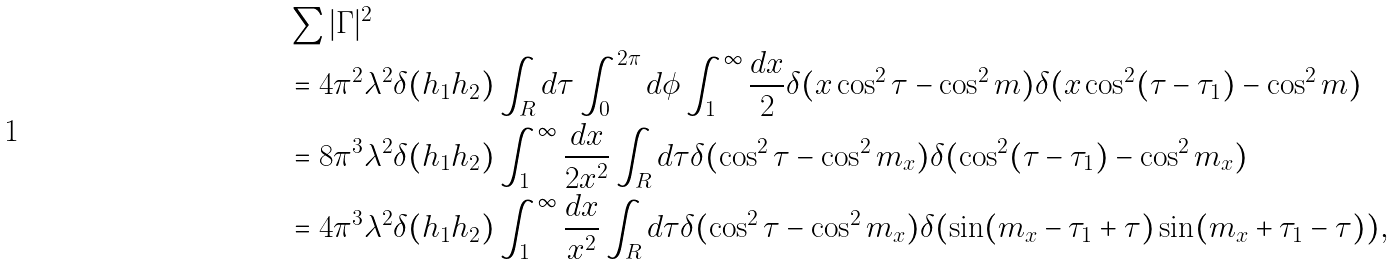Convert formula to latex. <formula><loc_0><loc_0><loc_500><loc_500>& \sum | \Gamma | ^ { 2 } \\ & = 4 \pi ^ { 2 } \lambda ^ { 2 } \delta ( h _ { 1 } h _ { 2 } ) \int _ { R } d \tau \int _ { 0 } ^ { 2 \pi } d \phi \int _ { 1 } ^ { \infty } \frac { d x } { 2 } \delta ( x \cos ^ { 2 } \tau - \cos ^ { 2 } m ) \delta ( x \cos ^ { 2 } ( \tau - \tau _ { 1 } ) - \cos ^ { 2 } m ) \\ & = 8 \pi ^ { 3 } \lambda ^ { 2 } \delta ( h _ { 1 } h _ { 2 } ) \int _ { 1 } ^ { \infty } \frac { d x } { 2 x ^ { 2 } } \int _ { R } d \tau \delta ( \cos ^ { 2 } \tau - \cos ^ { 2 } m _ { x } ) \delta ( \cos ^ { 2 } ( \tau - \tau _ { 1 } ) - \cos ^ { 2 } m _ { x } ) \\ & = 4 \pi ^ { 3 } \lambda ^ { 2 } \delta ( h _ { 1 } h _ { 2 } ) \int _ { 1 } ^ { \infty } \frac { d x } { x ^ { 2 } } \int _ { R } d \tau \delta ( \cos ^ { 2 } \tau - \cos ^ { 2 } m _ { x } ) \delta ( \sin ( m _ { x } - \tau _ { 1 } + \tau ) \sin ( m _ { x } + \tau _ { 1 } - \tau ) ) ,</formula> 